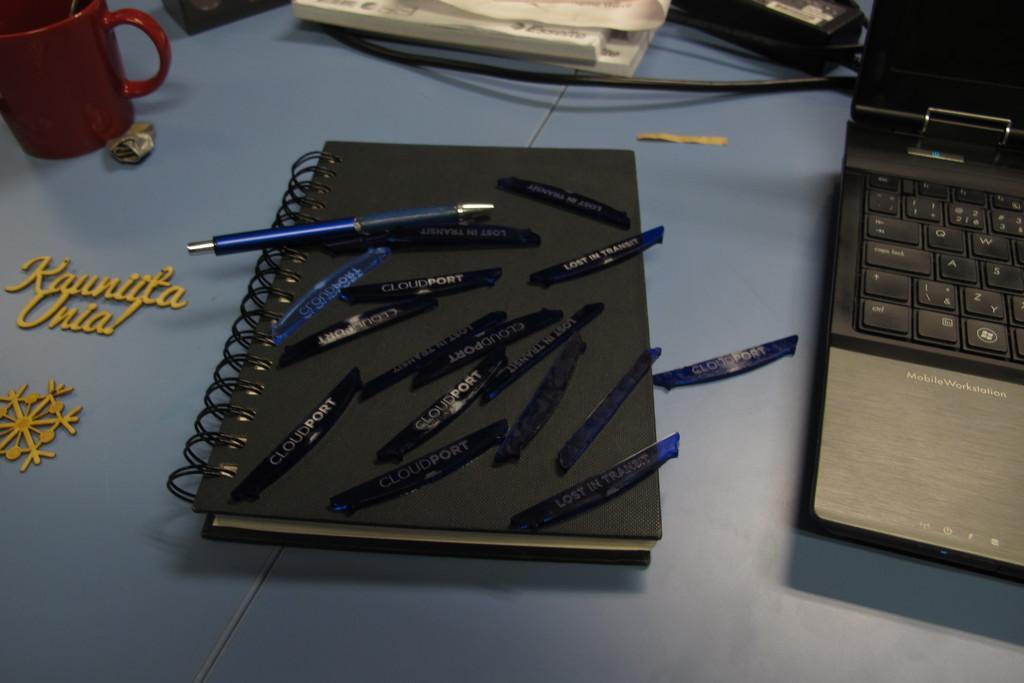Please provide a concise description of this image. In this picture we can see a table, on the right side there is a laptop, we can see books, a mug, a wire and name plates present on the table, we can see a pen on the book. 